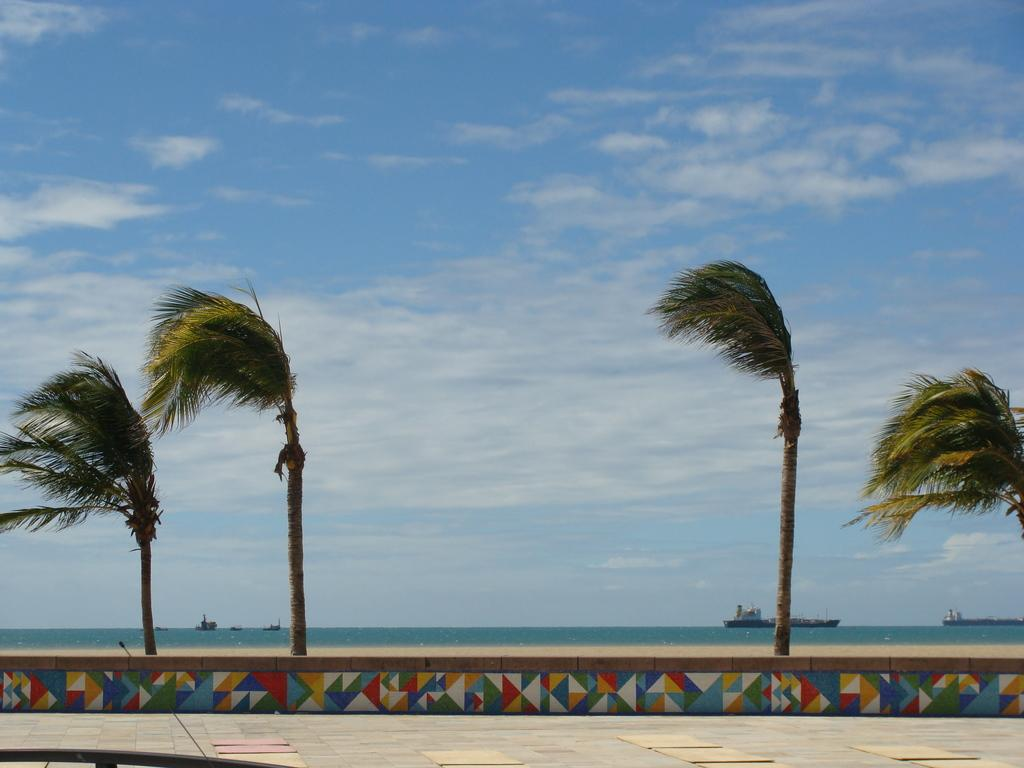What is at the bottom of the image? There is a floor at the bottom of the image. What type of vegetation can be seen in the image? There are trees in the image. What is located in the foreground of the image? There is a curb in the foreground of the image. What can be seen in the background of the image? There are ships in the background of the image. What is visible at the top of the image? There is sky at the top of the image. Is there any water visible in the image? Yes, there is water visible in the image. Where is the kitty playing with the waste in the image? There is no kitty or waste present in the image. What type of train can be seen passing by in the image? There is no train visible in the image. 